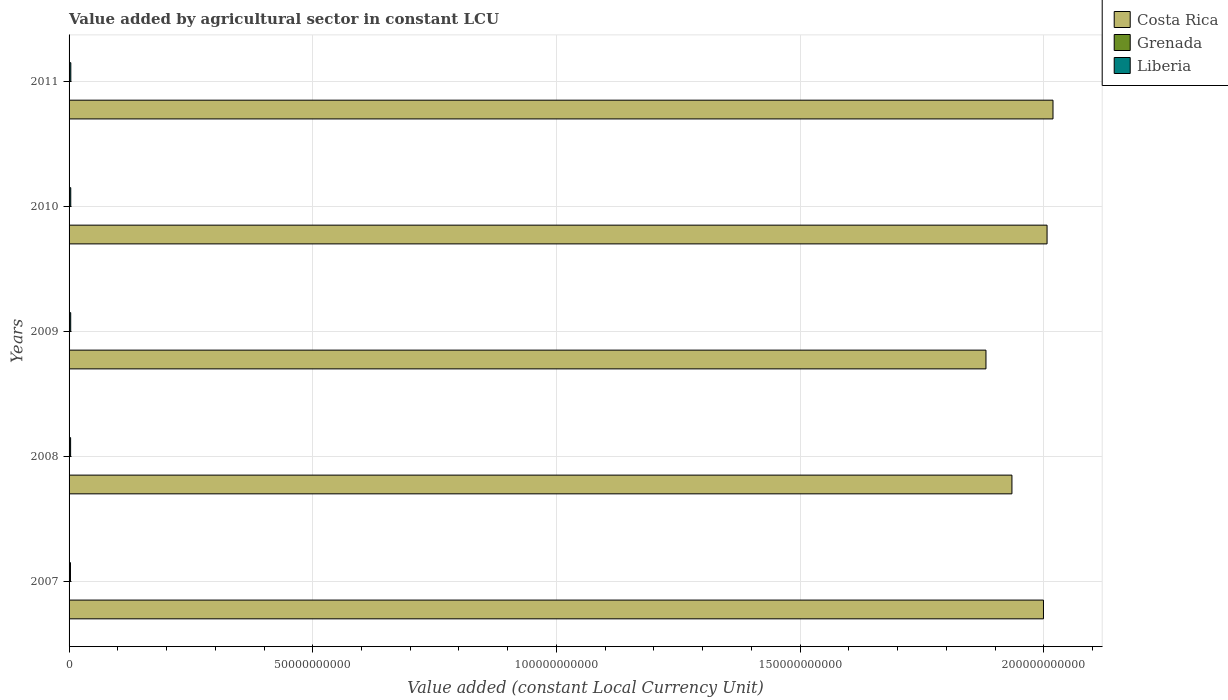How many different coloured bars are there?
Your answer should be compact. 3. Are the number of bars per tick equal to the number of legend labels?
Offer a terse response. Yes. Are the number of bars on each tick of the Y-axis equal?
Make the answer very short. Yes. How many bars are there on the 5th tick from the top?
Give a very brief answer. 3. How many bars are there on the 2nd tick from the bottom?
Ensure brevity in your answer.  3. What is the label of the 5th group of bars from the top?
Ensure brevity in your answer.  2007. In how many cases, is the number of bars for a given year not equal to the number of legend labels?
Offer a very short reply. 0. What is the value added by agricultural sector in Costa Rica in 2010?
Offer a very short reply. 2.01e+11. Across all years, what is the maximum value added by agricultural sector in Grenada?
Offer a very short reply. 9.17e+07. Across all years, what is the minimum value added by agricultural sector in Costa Rica?
Offer a very short reply. 1.88e+11. In which year was the value added by agricultural sector in Liberia maximum?
Provide a short and direct response. 2011. In which year was the value added by agricultural sector in Costa Rica minimum?
Your answer should be very brief. 2009. What is the total value added by agricultural sector in Costa Rica in the graph?
Give a very brief answer. 9.84e+11. What is the difference between the value added by agricultural sector in Grenada in 2009 and that in 2011?
Offer a terse response. 7.34e+06. What is the difference between the value added by agricultural sector in Costa Rica in 2011 and the value added by agricultural sector in Liberia in 2008?
Offer a very short reply. 2.02e+11. What is the average value added by agricultural sector in Costa Rica per year?
Offer a terse response. 1.97e+11. In the year 2008, what is the difference between the value added by agricultural sector in Liberia and value added by agricultural sector in Grenada?
Provide a short and direct response. 2.35e+08. What is the ratio of the value added by agricultural sector in Grenada in 2009 to that in 2010?
Your answer should be very brief. 1.07. Is the value added by agricultural sector in Liberia in 2007 less than that in 2010?
Provide a short and direct response. Yes. Is the difference between the value added by agricultural sector in Liberia in 2008 and 2010 greater than the difference between the value added by agricultural sector in Grenada in 2008 and 2010?
Offer a very short reply. No. What is the difference between the highest and the second highest value added by agricultural sector in Liberia?
Make the answer very short. 1.34e+07. What is the difference between the highest and the lowest value added by agricultural sector in Grenada?
Offer a terse response. 1.71e+07. In how many years, is the value added by agricultural sector in Grenada greater than the average value added by agricultural sector in Grenada taken over all years?
Offer a terse response. 3. Is the sum of the value added by agricultural sector in Costa Rica in 2007 and 2011 greater than the maximum value added by agricultural sector in Liberia across all years?
Your response must be concise. Yes. What does the 2nd bar from the top in 2009 represents?
Your answer should be compact. Grenada. What does the 2nd bar from the bottom in 2010 represents?
Give a very brief answer. Grenada. Is it the case that in every year, the sum of the value added by agricultural sector in Grenada and value added by agricultural sector in Costa Rica is greater than the value added by agricultural sector in Liberia?
Provide a succinct answer. Yes. How many bars are there?
Make the answer very short. 15. Are all the bars in the graph horizontal?
Give a very brief answer. Yes. How many years are there in the graph?
Provide a short and direct response. 5. Are the values on the major ticks of X-axis written in scientific E-notation?
Make the answer very short. No. Does the graph contain any zero values?
Keep it short and to the point. No. What is the title of the graph?
Offer a terse response. Value added by agricultural sector in constant LCU. What is the label or title of the X-axis?
Ensure brevity in your answer.  Value added (constant Local Currency Unit). What is the Value added (constant Local Currency Unit) of Costa Rica in 2007?
Provide a short and direct response. 2.00e+11. What is the Value added (constant Local Currency Unit) in Grenada in 2007?
Give a very brief answer. 7.46e+07. What is the Value added (constant Local Currency Unit) in Liberia in 2007?
Your answer should be very brief. 2.87e+08. What is the Value added (constant Local Currency Unit) of Costa Rica in 2008?
Provide a short and direct response. 1.93e+11. What is the Value added (constant Local Currency Unit) in Grenada in 2008?
Make the answer very short. 8.18e+07. What is the Value added (constant Local Currency Unit) of Liberia in 2008?
Your response must be concise. 3.17e+08. What is the Value added (constant Local Currency Unit) in Costa Rica in 2009?
Keep it short and to the point. 1.88e+11. What is the Value added (constant Local Currency Unit) in Grenada in 2009?
Offer a very short reply. 9.17e+07. What is the Value added (constant Local Currency Unit) in Liberia in 2009?
Keep it short and to the point. 3.33e+08. What is the Value added (constant Local Currency Unit) in Costa Rica in 2010?
Your response must be concise. 2.01e+11. What is the Value added (constant Local Currency Unit) of Grenada in 2010?
Provide a succinct answer. 8.57e+07. What is the Value added (constant Local Currency Unit) in Liberia in 2010?
Ensure brevity in your answer.  3.45e+08. What is the Value added (constant Local Currency Unit) of Costa Rica in 2011?
Your response must be concise. 2.02e+11. What is the Value added (constant Local Currency Unit) of Grenada in 2011?
Your response must be concise. 8.44e+07. What is the Value added (constant Local Currency Unit) in Liberia in 2011?
Provide a succinct answer. 3.59e+08. Across all years, what is the maximum Value added (constant Local Currency Unit) of Costa Rica?
Give a very brief answer. 2.02e+11. Across all years, what is the maximum Value added (constant Local Currency Unit) in Grenada?
Offer a very short reply. 9.17e+07. Across all years, what is the maximum Value added (constant Local Currency Unit) of Liberia?
Make the answer very short. 3.59e+08. Across all years, what is the minimum Value added (constant Local Currency Unit) of Costa Rica?
Offer a very short reply. 1.88e+11. Across all years, what is the minimum Value added (constant Local Currency Unit) of Grenada?
Provide a succinct answer. 7.46e+07. Across all years, what is the minimum Value added (constant Local Currency Unit) of Liberia?
Your answer should be compact. 2.87e+08. What is the total Value added (constant Local Currency Unit) in Costa Rica in the graph?
Make the answer very short. 9.84e+11. What is the total Value added (constant Local Currency Unit) of Grenada in the graph?
Your answer should be very brief. 4.18e+08. What is the total Value added (constant Local Currency Unit) of Liberia in the graph?
Your answer should be compact. 1.64e+09. What is the difference between the Value added (constant Local Currency Unit) in Costa Rica in 2007 and that in 2008?
Your answer should be very brief. 6.47e+09. What is the difference between the Value added (constant Local Currency Unit) of Grenada in 2007 and that in 2008?
Your response must be concise. -7.21e+06. What is the difference between the Value added (constant Local Currency Unit) in Liberia in 2007 and that in 2008?
Your response must be concise. -3.02e+07. What is the difference between the Value added (constant Local Currency Unit) in Costa Rica in 2007 and that in 2009?
Offer a very short reply. 1.18e+1. What is the difference between the Value added (constant Local Currency Unit) in Grenada in 2007 and that in 2009?
Provide a succinct answer. -1.71e+07. What is the difference between the Value added (constant Local Currency Unit) of Liberia in 2007 and that in 2009?
Offer a very short reply. -4.69e+07. What is the difference between the Value added (constant Local Currency Unit) in Costa Rica in 2007 and that in 2010?
Give a very brief answer. -7.38e+08. What is the difference between the Value added (constant Local Currency Unit) in Grenada in 2007 and that in 2010?
Give a very brief answer. -1.11e+07. What is the difference between the Value added (constant Local Currency Unit) in Liberia in 2007 and that in 2010?
Provide a short and direct response. -5.89e+07. What is the difference between the Value added (constant Local Currency Unit) of Costa Rica in 2007 and that in 2011?
Ensure brevity in your answer.  -1.95e+09. What is the difference between the Value added (constant Local Currency Unit) in Grenada in 2007 and that in 2011?
Make the answer very short. -9.78e+06. What is the difference between the Value added (constant Local Currency Unit) in Liberia in 2007 and that in 2011?
Offer a very short reply. -7.24e+07. What is the difference between the Value added (constant Local Currency Unit) of Costa Rica in 2008 and that in 2009?
Give a very brief answer. 5.33e+09. What is the difference between the Value added (constant Local Currency Unit) of Grenada in 2008 and that in 2009?
Provide a succinct answer. -9.92e+06. What is the difference between the Value added (constant Local Currency Unit) of Liberia in 2008 and that in 2009?
Provide a short and direct response. -1.67e+07. What is the difference between the Value added (constant Local Currency Unit) of Costa Rica in 2008 and that in 2010?
Your answer should be compact. -7.21e+09. What is the difference between the Value added (constant Local Currency Unit) of Grenada in 2008 and that in 2010?
Keep it short and to the point. -3.92e+06. What is the difference between the Value added (constant Local Currency Unit) of Liberia in 2008 and that in 2010?
Give a very brief answer. -2.87e+07. What is the difference between the Value added (constant Local Currency Unit) of Costa Rica in 2008 and that in 2011?
Give a very brief answer. -8.43e+09. What is the difference between the Value added (constant Local Currency Unit) of Grenada in 2008 and that in 2011?
Ensure brevity in your answer.  -2.58e+06. What is the difference between the Value added (constant Local Currency Unit) of Liberia in 2008 and that in 2011?
Provide a succinct answer. -4.21e+07. What is the difference between the Value added (constant Local Currency Unit) in Costa Rica in 2009 and that in 2010?
Provide a short and direct response. -1.25e+1. What is the difference between the Value added (constant Local Currency Unit) in Grenada in 2009 and that in 2010?
Provide a succinct answer. 6.00e+06. What is the difference between the Value added (constant Local Currency Unit) in Liberia in 2009 and that in 2010?
Provide a short and direct response. -1.20e+07. What is the difference between the Value added (constant Local Currency Unit) in Costa Rica in 2009 and that in 2011?
Give a very brief answer. -1.38e+1. What is the difference between the Value added (constant Local Currency Unit) in Grenada in 2009 and that in 2011?
Make the answer very short. 7.34e+06. What is the difference between the Value added (constant Local Currency Unit) of Liberia in 2009 and that in 2011?
Keep it short and to the point. -2.54e+07. What is the difference between the Value added (constant Local Currency Unit) of Costa Rica in 2010 and that in 2011?
Provide a succinct answer. -1.22e+09. What is the difference between the Value added (constant Local Currency Unit) of Grenada in 2010 and that in 2011?
Make the answer very short. 1.34e+06. What is the difference between the Value added (constant Local Currency Unit) of Liberia in 2010 and that in 2011?
Ensure brevity in your answer.  -1.34e+07. What is the difference between the Value added (constant Local Currency Unit) in Costa Rica in 2007 and the Value added (constant Local Currency Unit) in Grenada in 2008?
Make the answer very short. 2.00e+11. What is the difference between the Value added (constant Local Currency Unit) of Costa Rica in 2007 and the Value added (constant Local Currency Unit) of Liberia in 2008?
Offer a very short reply. 2.00e+11. What is the difference between the Value added (constant Local Currency Unit) in Grenada in 2007 and the Value added (constant Local Currency Unit) in Liberia in 2008?
Your answer should be compact. -2.42e+08. What is the difference between the Value added (constant Local Currency Unit) of Costa Rica in 2007 and the Value added (constant Local Currency Unit) of Grenada in 2009?
Ensure brevity in your answer.  2.00e+11. What is the difference between the Value added (constant Local Currency Unit) in Costa Rica in 2007 and the Value added (constant Local Currency Unit) in Liberia in 2009?
Your answer should be compact. 2.00e+11. What is the difference between the Value added (constant Local Currency Unit) of Grenada in 2007 and the Value added (constant Local Currency Unit) of Liberia in 2009?
Provide a succinct answer. -2.59e+08. What is the difference between the Value added (constant Local Currency Unit) of Costa Rica in 2007 and the Value added (constant Local Currency Unit) of Grenada in 2010?
Your response must be concise. 2.00e+11. What is the difference between the Value added (constant Local Currency Unit) in Costa Rica in 2007 and the Value added (constant Local Currency Unit) in Liberia in 2010?
Keep it short and to the point. 2.00e+11. What is the difference between the Value added (constant Local Currency Unit) of Grenada in 2007 and the Value added (constant Local Currency Unit) of Liberia in 2010?
Provide a succinct answer. -2.71e+08. What is the difference between the Value added (constant Local Currency Unit) of Costa Rica in 2007 and the Value added (constant Local Currency Unit) of Grenada in 2011?
Offer a very short reply. 2.00e+11. What is the difference between the Value added (constant Local Currency Unit) in Costa Rica in 2007 and the Value added (constant Local Currency Unit) in Liberia in 2011?
Give a very brief answer. 2.00e+11. What is the difference between the Value added (constant Local Currency Unit) of Grenada in 2007 and the Value added (constant Local Currency Unit) of Liberia in 2011?
Offer a terse response. -2.84e+08. What is the difference between the Value added (constant Local Currency Unit) in Costa Rica in 2008 and the Value added (constant Local Currency Unit) in Grenada in 2009?
Offer a terse response. 1.93e+11. What is the difference between the Value added (constant Local Currency Unit) in Costa Rica in 2008 and the Value added (constant Local Currency Unit) in Liberia in 2009?
Make the answer very short. 1.93e+11. What is the difference between the Value added (constant Local Currency Unit) of Grenada in 2008 and the Value added (constant Local Currency Unit) of Liberia in 2009?
Keep it short and to the point. -2.52e+08. What is the difference between the Value added (constant Local Currency Unit) of Costa Rica in 2008 and the Value added (constant Local Currency Unit) of Grenada in 2010?
Your answer should be compact. 1.93e+11. What is the difference between the Value added (constant Local Currency Unit) of Costa Rica in 2008 and the Value added (constant Local Currency Unit) of Liberia in 2010?
Ensure brevity in your answer.  1.93e+11. What is the difference between the Value added (constant Local Currency Unit) of Grenada in 2008 and the Value added (constant Local Currency Unit) of Liberia in 2010?
Provide a short and direct response. -2.64e+08. What is the difference between the Value added (constant Local Currency Unit) in Costa Rica in 2008 and the Value added (constant Local Currency Unit) in Grenada in 2011?
Ensure brevity in your answer.  1.93e+11. What is the difference between the Value added (constant Local Currency Unit) of Costa Rica in 2008 and the Value added (constant Local Currency Unit) of Liberia in 2011?
Provide a short and direct response. 1.93e+11. What is the difference between the Value added (constant Local Currency Unit) of Grenada in 2008 and the Value added (constant Local Currency Unit) of Liberia in 2011?
Make the answer very short. -2.77e+08. What is the difference between the Value added (constant Local Currency Unit) in Costa Rica in 2009 and the Value added (constant Local Currency Unit) in Grenada in 2010?
Offer a terse response. 1.88e+11. What is the difference between the Value added (constant Local Currency Unit) of Costa Rica in 2009 and the Value added (constant Local Currency Unit) of Liberia in 2010?
Your response must be concise. 1.88e+11. What is the difference between the Value added (constant Local Currency Unit) of Grenada in 2009 and the Value added (constant Local Currency Unit) of Liberia in 2010?
Ensure brevity in your answer.  -2.54e+08. What is the difference between the Value added (constant Local Currency Unit) in Costa Rica in 2009 and the Value added (constant Local Currency Unit) in Grenada in 2011?
Provide a short and direct response. 1.88e+11. What is the difference between the Value added (constant Local Currency Unit) in Costa Rica in 2009 and the Value added (constant Local Currency Unit) in Liberia in 2011?
Keep it short and to the point. 1.88e+11. What is the difference between the Value added (constant Local Currency Unit) of Grenada in 2009 and the Value added (constant Local Currency Unit) of Liberia in 2011?
Your response must be concise. -2.67e+08. What is the difference between the Value added (constant Local Currency Unit) of Costa Rica in 2010 and the Value added (constant Local Currency Unit) of Grenada in 2011?
Make the answer very short. 2.01e+11. What is the difference between the Value added (constant Local Currency Unit) of Costa Rica in 2010 and the Value added (constant Local Currency Unit) of Liberia in 2011?
Make the answer very short. 2.00e+11. What is the difference between the Value added (constant Local Currency Unit) of Grenada in 2010 and the Value added (constant Local Currency Unit) of Liberia in 2011?
Ensure brevity in your answer.  -2.73e+08. What is the average Value added (constant Local Currency Unit) of Costa Rica per year?
Provide a short and direct response. 1.97e+11. What is the average Value added (constant Local Currency Unit) of Grenada per year?
Keep it short and to the point. 8.37e+07. What is the average Value added (constant Local Currency Unit) of Liberia per year?
Give a very brief answer. 3.28e+08. In the year 2007, what is the difference between the Value added (constant Local Currency Unit) of Costa Rica and Value added (constant Local Currency Unit) of Grenada?
Your response must be concise. 2.00e+11. In the year 2007, what is the difference between the Value added (constant Local Currency Unit) in Costa Rica and Value added (constant Local Currency Unit) in Liberia?
Provide a succinct answer. 2.00e+11. In the year 2007, what is the difference between the Value added (constant Local Currency Unit) in Grenada and Value added (constant Local Currency Unit) in Liberia?
Give a very brief answer. -2.12e+08. In the year 2008, what is the difference between the Value added (constant Local Currency Unit) of Costa Rica and Value added (constant Local Currency Unit) of Grenada?
Your answer should be compact. 1.93e+11. In the year 2008, what is the difference between the Value added (constant Local Currency Unit) in Costa Rica and Value added (constant Local Currency Unit) in Liberia?
Provide a short and direct response. 1.93e+11. In the year 2008, what is the difference between the Value added (constant Local Currency Unit) in Grenada and Value added (constant Local Currency Unit) in Liberia?
Your response must be concise. -2.35e+08. In the year 2009, what is the difference between the Value added (constant Local Currency Unit) of Costa Rica and Value added (constant Local Currency Unit) of Grenada?
Ensure brevity in your answer.  1.88e+11. In the year 2009, what is the difference between the Value added (constant Local Currency Unit) in Costa Rica and Value added (constant Local Currency Unit) in Liberia?
Offer a very short reply. 1.88e+11. In the year 2009, what is the difference between the Value added (constant Local Currency Unit) in Grenada and Value added (constant Local Currency Unit) in Liberia?
Your response must be concise. -2.42e+08. In the year 2010, what is the difference between the Value added (constant Local Currency Unit) in Costa Rica and Value added (constant Local Currency Unit) in Grenada?
Offer a very short reply. 2.01e+11. In the year 2010, what is the difference between the Value added (constant Local Currency Unit) in Costa Rica and Value added (constant Local Currency Unit) in Liberia?
Provide a succinct answer. 2.00e+11. In the year 2010, what is the difference between the Value added (constant Local Currency Unit) of Grenada and Value added (constant Local Currency Unit) of Liberia?
Offer a very short reply. -2.60e+08. In the year 2011, what is the difference between the Value added (constant Local Currency Unit) of Costa Rica and Value added (constant Local Currency Unit) of Grenada?
Your response must be concise. 2.02e+11. In the year 2011, what is the difference between the Value added (constant Local Currency Unit) of Costa Rica and Value added (constant Local Currency Unit) of Liberia?
Give a very brief answer. 2.02e+11. In the year 2011, what is the difference between the Value added (constant Local Currency Unit) in Grenada and Value added (constant Local Currency Unit) in Liberia?
Offer a very short reply. -2.75e+08. What is the ratio of the Value added (constant Local Currency Unit) of Costa Rica in 2007 to that in 2008?
Your answer should be compact. 1.03. What is the ratio of the Value added (constant Local Currency Unit) in Grenada in 2007 to that in 2008?
Provide a short and direct response. 0.91. What is the ratio of the Value added (constant Local Currency Unit) of Liberia in 2007 to that in 2008?
Offer a terse response. 0.9. What is the ratio of the Value added (constant Local Currency Unit) of Costa Rica in 2007 to that in 2009?
Offer a terse response. 1.06. What is the ratio of the Value added (constant Local Currency Unit) in Grenada in 2007 to that in 2009?
Offer a terse response. 0.81. What is the ratio of the Value added (constant Local Currency Unit) of Liberia in 2007 to that in 2009?
Provide a succinct answer. 0.86. What is the ratio of the Value added (constant Local Currency Unit) of Grenada in 2007 to that in 2010?
Your response must be concise. 0.87. What is the ratio of the Value added (constant Local Currency Unit) of Liberia in 2007 to that in 2010?
Offer a terse response. 0.83. What is the ratio of the Value added (constant Local Currency Unit) of Costa Rica in 2007 to that in 2011?
Give a very brief answer. 0.99. What is the ratio of the Value added (constant Local Currency Unit) of Grenada in 2007 to that in 2011?
Your answer should be compact. 0.88. What is the ratio of the Value added (constant Local Currency Unit) in Liberia in 2007 to that in 2011?
Your response must be concise. 0.8. What is the ratio of the Value added (constant Local Currency Unit) of Costa Rica in 2008 to that in 2009?
Give a very brief answer. 1.03. What is the ratio of the Value added (constant Local Currency Unit) of Grenada in 2008 to that in 2009?
Make the answer very short. 0.89. What is the ratio of the Value added (constant Local Currency Unit) in Costa Rica in 2008 to that in 2010?
Your response must be concise. 0.96. What is the ratio of the Value added (constant Local Currency Unit) of Grenada in 2008 to that in 2010?
Provide a short and direct response. 0.95. What is the ratio of the Value added (constant Local Currency Unit) in Liberia in 2008 to that in 2010?
Offer a very short reply. 0.92. What is the ratio of the Value added (constant Local Currency Unit) of Grenada in 2008 to that in 2011?
Offer a terse response. 0.97. What is the ratio of the Value added (constant Local Currency Unit) in Liberia in 2008 to that in 2011?
Offer a very short reply. 0.88. What is the ratio of the Value added (constant Local Currency Unit) in Grenada in 2009 to that in 2010?
Offer a very short reply. 1.07. What is the ratio of the Value added (constant Local Currency Unit) in Liberia in 2009 to that in 2010?
Give a very brief answer. 0.97. What is the ratio of the Value added (constant Local Currency Unit) in Costa Rica in 2009 to that in 2011?
Your answer should be very brief. 0.93. What is the ratio of the Value added (constant Local Currency Unit) in Grenada in 2009 to that in 2011?
Your answer should be very brief. 1.09. What is the ratio of the Value added (constant Local Currency Unit) in Liberia in 2009 to that in 2011?
Your answer should be compact. 0.93. What is the ratio of the Value added (constant Local Currency Unit) of Costa Rica in 2010 to that in 2011?
Ensure brevity in your answer.  0.99. What is the ratio of the Value added (constant Local Currency Unit) of Grenada in 2010 to that in 2011?
Provide a short and direct response. 1.02. What is the ratio of the Value added (constant Local Currency Unit) of Liberia in 2010 to that in 2011?
Make the answer very short. 0.96. What is the difference between the highest and the second highest Value added (constant Local Currency Unit) of Costa Rica?
Keep it short and to the point. 1.22e+09. What is the difference between the highest and the second highest Value added (constant Local Currency Unit) in Grenada?
Your response must be concise. 6.00e+06. What is the difference between the highest and the second highest Value added (constant Local Currency Unit) of Liberia?
Your answer should be compact. 1.34e+07. What is the difference between the highest and the lowest Value added (constant Local Currency Unit) of Costa Rica?
Ensure brevity in your answer.  1.38e+1. What is the difference between the highest and the lowest Value added (constant Local Currency Unit) of Grenada?
Your answer should be compact. 1.71e+07. What is the difference between the highest and the lowest Value added (constant Local Currency Unit) of Liberia?
Offer a very short reply. 7.24e+07. 